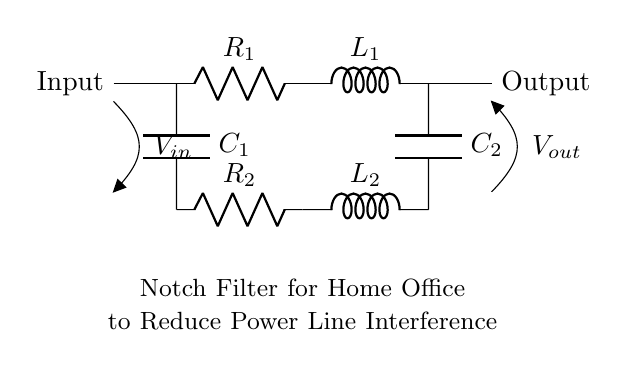What is the type of this filter? The circuit is a notch filter, which is designed to attenuate a specific frequency while allowing others to pass. This is evident from the presence of both inductors and capacitors, which are common in filter designs.
Answer: notch filter How many resistors are in the circuit? There are two resistors present in the circuit, denoted as R1 and R2. Both are clearly labeled in the diagram.
Answer: two What does the input voltage represent? The input voltage, labeled as V in, indicates the voltage that is applied at the input of the circuit. This is where the signal enters the filter before any processing occurs.
Answer: V in Which component is closest to the output? The last component before the output is capacitor C2, which is closest to the output terminal in the circuit layout. This positioning is typical for delivering the filtered signal.
Answer: C2 What is the function of the inductors in this circuit? The inductors, L1 and L2, work together with the capacitors to create the notch filtering effect. They help define the resonant frequency that the filter will reduce, thereby addressing unwanted frequencies.
Answer: filtering What does the label "Notch Filter for Home Office" indicate? This label serves to clarify the purpose of the circuit, suggesting that it is specifically designed to reduce interference in a home office environment. It indicates both the function and context of application.
Answer: purpose 